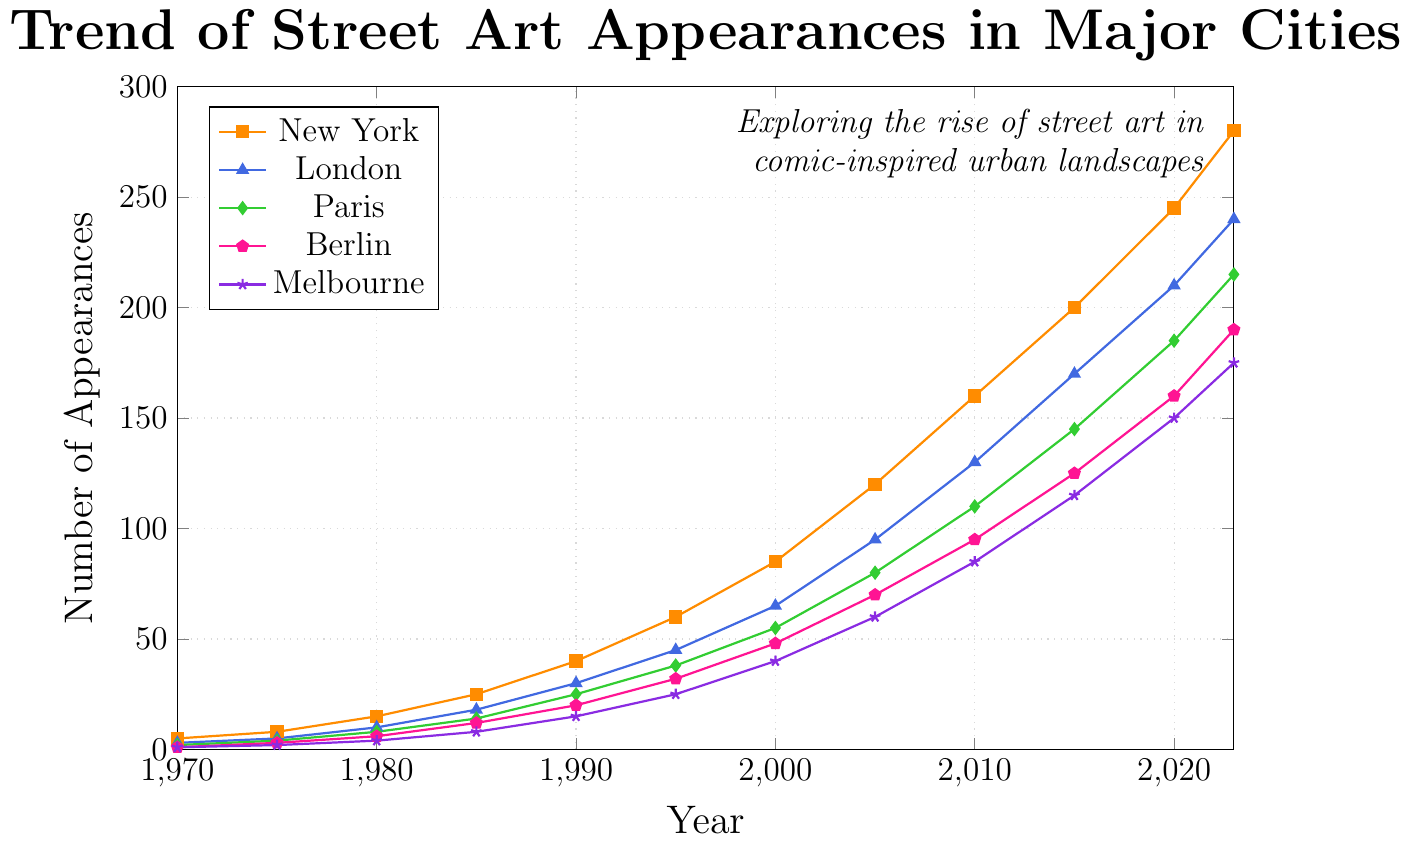Which city had the highest number of street art appearances in 2023? In the year 2023, New York had the highest number of street art appearances compared to the other cities shown on the chart. The number for New York is around 280, which is higher than the rest.
Answer: New York By how much did street art appearances increase in London from 1970 to 2023? To find the increase in street art appearances in London, subtract the number of appearances in 1970 from the number in 2023. The figures are 240 (2023) - 3 (1970) = 237.
Answer: 237 Which city showed the steepest increase in street art appearances between 2000 and 2010? To determine which city showed the steepest increase between 2000 and 2010, calculate the difference for each city: 
- New York: 160 - 85 = 75
- London: 130 - 65 = 65
- Paris: 110 - 55 = 55
- Berlin: 95 - 48 = 47
- Melbourne: 85 - 40 = 45
New York had the steepest increase of 75.
Answer: New York Compare the number of street art appearances in Paris and Berlin in 2020. Which city had more, and by how much? To compare the numbers, we look at the chart for 2020:
- Paris: 185
- Berlin: 160
Paris had more street art appearances than Berlin by 185 - 160 = 25.
Answer: Paris by 25 What is the average number of street art appearances in Melbourne between 1970 and 2023? Calculate the average for Melbourne by summing the values from each year and dividing by the number of years:
(1 + 2 + 4 + 8 + 15 + 25 + 40 + 60 + 85 + 115 + 150 + 175) / 12 = 680 / 12 ≈ 56.67.
Answer: 56.67 In which year did New York surpass 100 street art appearances and how do we verify it through the chart? By examining the chart, New York surpassed 100 street art appearances between 2000 (85) and 2005 (120). Therefore, the year New York surpassed 100 is 2005.
Answer: 2005 Which city had the lowest number of appearances in 1970 and how many? Look at the values for 1970 for each city; Berlin and Melbourne both had the lowest with 1 street art appearance each.
Answer: Berlin and Melbourne, 1 What was the total number of street art appearances across all cities in 1995? Sum the street art appearances for all cities in 1995:
60 (New York) + 45 (London) + 38 (Paris) + 32 (Berlin) + 25 (Melbourne) = 200.
Answer: 200 How does the growth trend of street art in Berlin compare to that in Paris from 1980 to 2000? Calculate the increase for both cities from 1980 to 2000:
- Berlin: 48 - 6 = 42
- Paris: 55 - 8 = 47
Both cities exhibit growth, but Paris had slightly more with 47 compared to Berlin’s 42.
Answer: Paris had a slightly higher growth Which city had the highest growth rate between 1970 and 2023? To determine the highest growth rate, compare the initial and final values for each city.
- New York: (280 - 5) / 5 = 55
- London: (240 - 3) / 3 = 79
- Paris: (215 - 2) / 2 = 106.5
- Berlin: (190 - 1) / 1 = 189
- Melbourne: (175 - 1) / 1 = 174
Berlin had the highest growth rate.
Answer: Berlin 